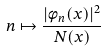Convert formula to latex. <formula><loc_0><loc_0><loc_500><loc_500>n \mapsto \frac { | \phi _ { n } ( x ) | ^ { 2 } } { N ( x ) }</formula> 